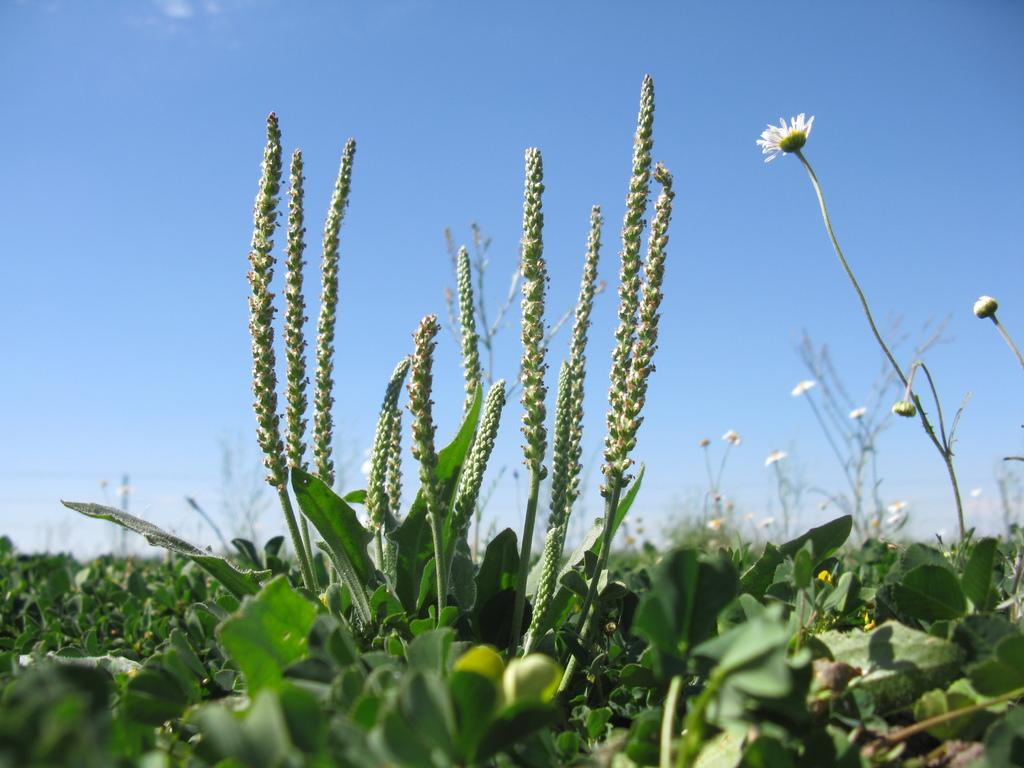What type of living organisms can be seen in the image? Plants and flowers are visible in the image. How is the background of the image depicted? The background of the image is blurred. What color is the sky visible in the background of the image? The blue color sky is visible in the background of the image. What type of error can be seen in the image? There is no error present in the image; it is a clear image of plants, flowers, and a blurred background with a blue sky. 